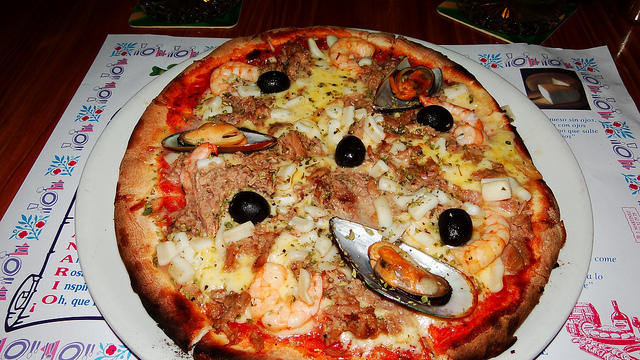Please identify all text content in this image. Oh que I nspi R os A e lo a come 